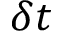Convert formula to latex. <formula><loc_0><loc_0><loc_500><loc_500>\delta t</formula> 